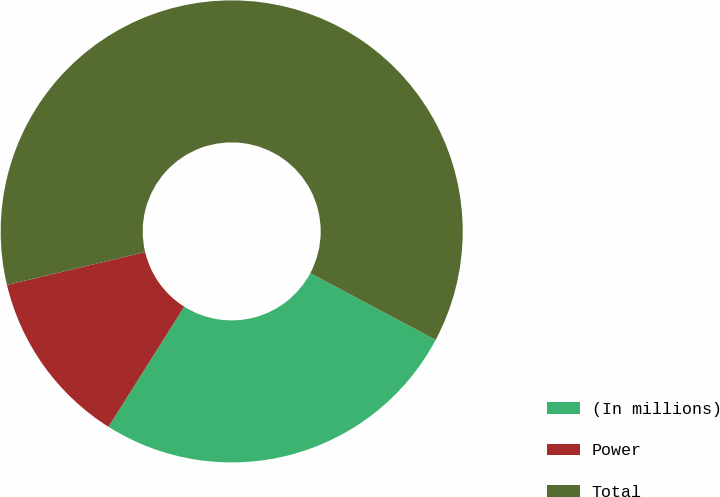<chart> <loc_0><loc_0><loc_500><loc_500><pie_chart><fcel>(In millions)<fcel>Power<fcel>Total<nl><fcel>26.18%<fcel>12.32%<fcel>61.5%<nl></chart> 